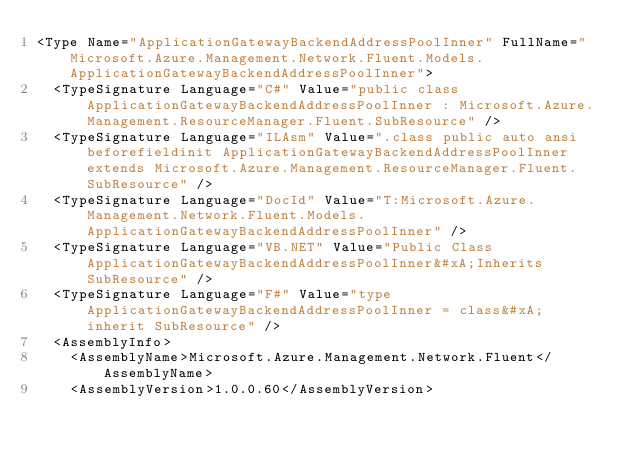Convert code to text. <code><loc_0><loc_0><loc_500><loc_500><_XML_><Type Name="ApplicationGatewayBackendAddressPoolInner" FullName="Microsoft.Azure.Management.Network.Fluent.Models.ApplicationGatewayBackendAddressPoolInner">
  <TypeSignature Language="C#" Value="public class ApplicationGatewayBackendAddressPoolInner : Microsoft.Azure.Management.ResourceManager.Fluent.SubResource" />
  <TypeSignature Language="ILAsm" Value=".class public auto ansi beforefieldinit ApplicationGatewayBackendAddressPoolInner extends Microsoft.Azure.Management.ResourceManager.Fluent.SubResource" />
  <TypeSignature Language="DocId" Value="T:Microsoft.Azure.Management.Network.Fluent.Models.ApplicationGatewayBackendAddressPoolInner" />
  <TypeSignature Language="VB.NET" Value="Public Class ApplicationGatewayBackendAddressPoolInner&#xA;Inherits SubResource" />
  <TypeSignature Language="F#" Value="type ApplicationGatewayBackendAddressPoolInner = class&#xA;    inherit SubResource" />
  <AssemblyInfo>
    <AssemblyName>Microsoft.Azure.Management.Network.Fluent</AssemblyName>
    <AssemblyVersion>1.0.0.60</AssemblyVersion></code> 